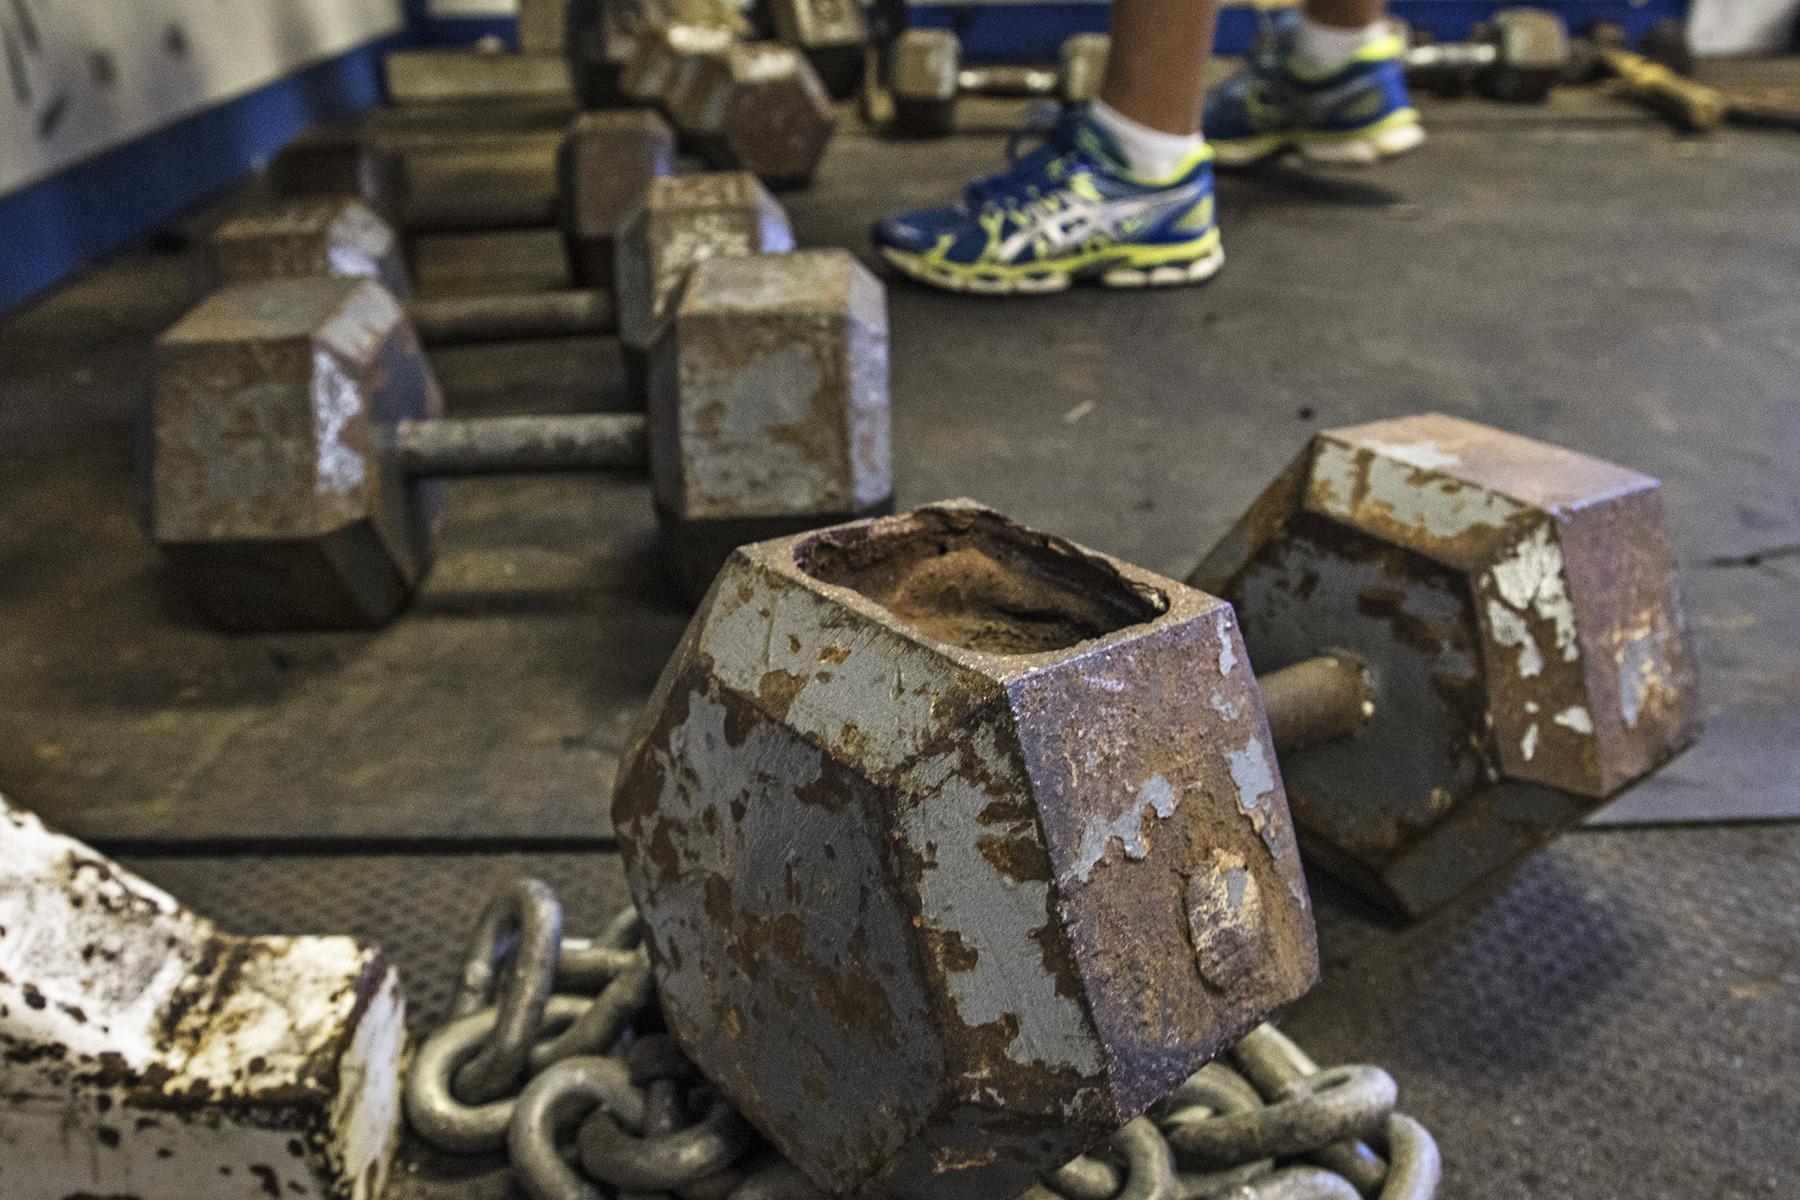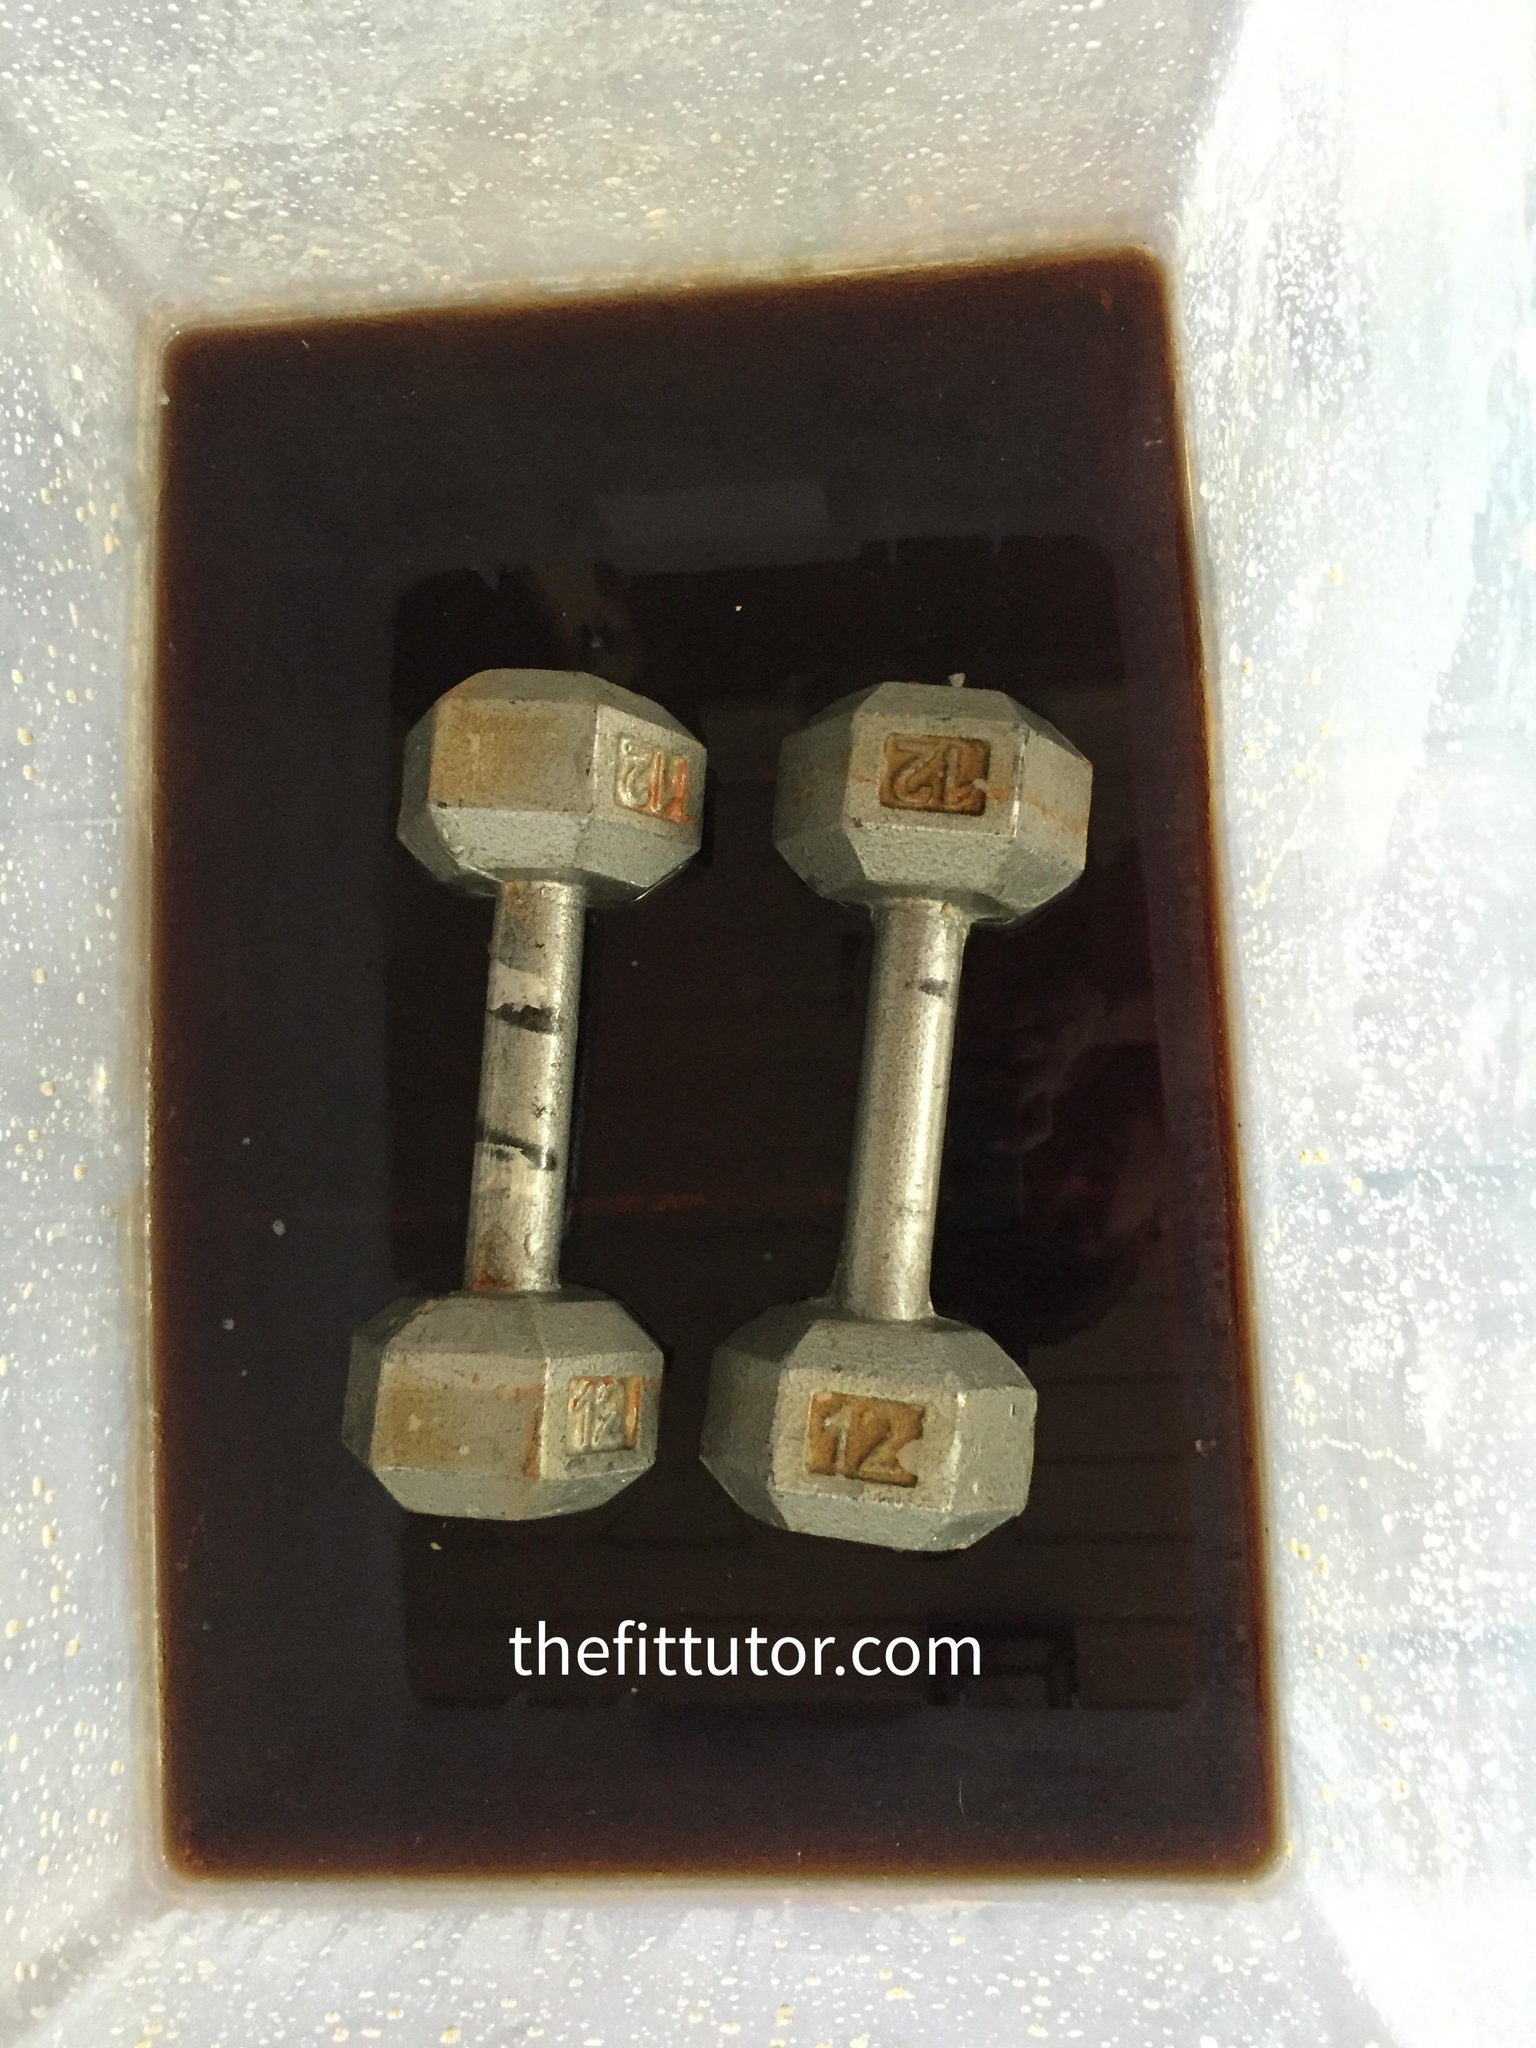The first image is the image on the left, the second image is the image on the right. Assess this claim about the two images: "There are exactly four objects.". Correct or not? Answer yes or no. No. The first image is the image on the left, the second image is the image on the right. Examine the images to the left and right. Is the description "One of the weights has tarnished brown surfaces." accurate? Answer yes or no. Yes. 